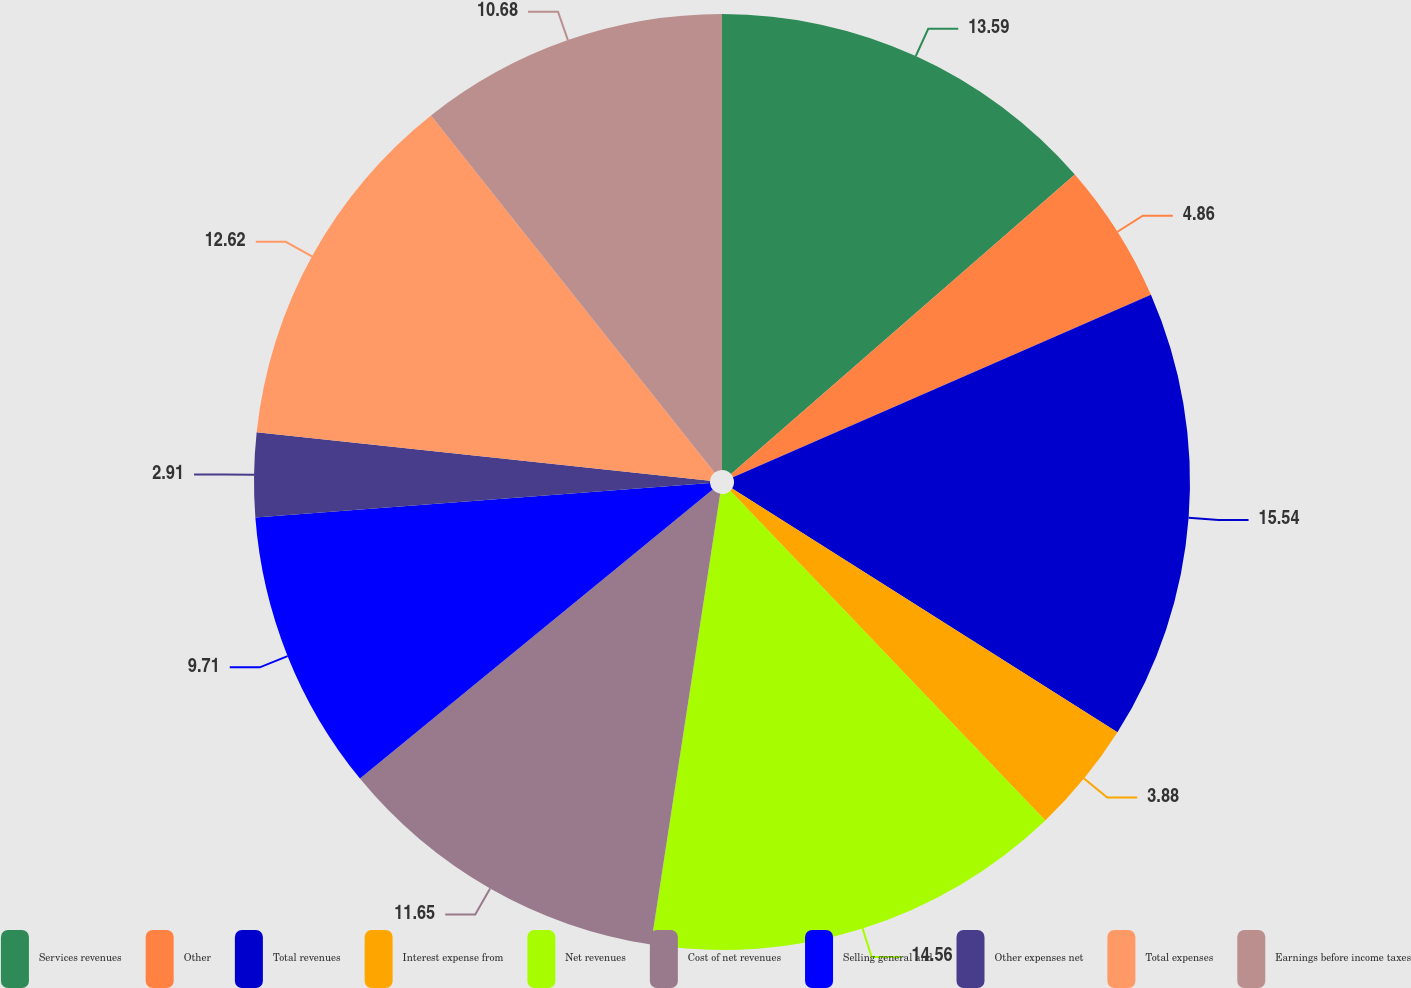<chart> <loc_0><loc_0><loc_500><loc_500><pie_chart><fcel>Services revenues<fcel>Other<fcel>Total revenues<fcel>Interest expense from<fcel>Net revenues<fcel>Cost of net revenues<fcel>Selling general and<fcel>Other expenses net<fcel>Total expenses<fcel>Earnings before income taxes<nl><fcel>13.59%<fcel>4.86%<fcel>15.53%<fcel>3.88%<fcel>14.56%<fcel>11.65%<fcel>9.71%<fcel>2.91%<fcel>12.62%<fcel>10.68%<nl></chart> 